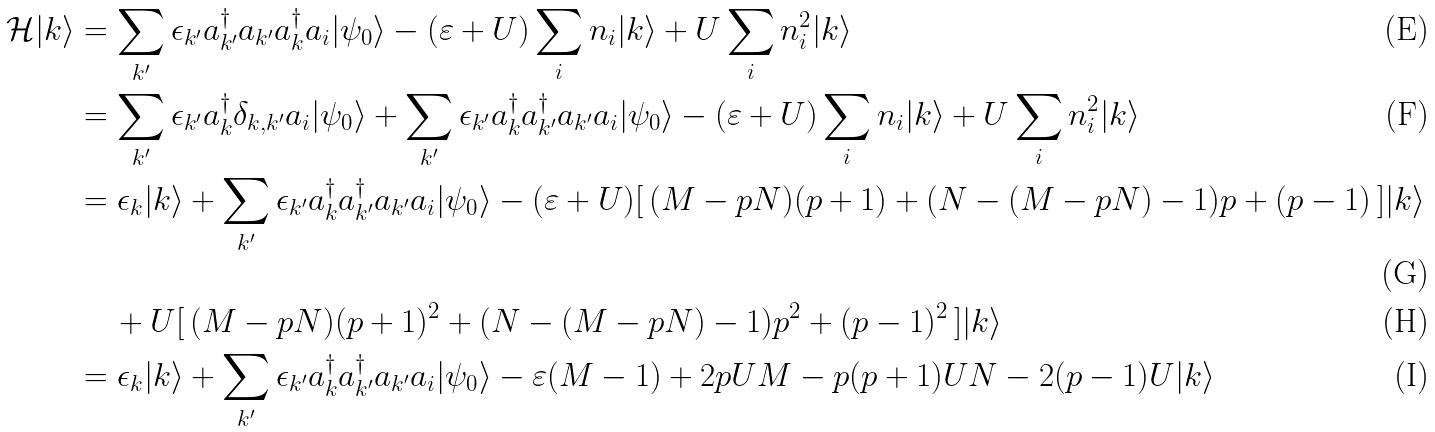<formula> <loc_0><loc_0><loc_500><loc_500>\mathcal { H } | { k } \rangle & = \sum _ { { k } ^ { \prime } } \epsilon _ { { k } ^ { \prime } } a _ { { k } ^ { \prime } } ^ { \dagger } a _ { { k } ^ { \prime } } a _ { k } ^ { \dagger } a _ { i } | \psi _ { 0 } \rangle - ( \varepsilon + U ) \sum _ { i } n _ { i } | { k } \rangle + U \sum _ { i } n _ { i } ^ { 2 } | { k } \rangle \\ & = \sum _ { { k } ^ { \prime } } \epsilon _ { { k } ^ { \prime } } a _ { k } ^ { \dagger } \delta _ { { k } , { { k } ^ { \prime } } } a _ { i } | \psi _ { 0 } \rangle + \sum _ { { k } ^ { \prime } } \epsilon _ { { k } ^ { \prime } } a _ { k } ^ { \dagger } a _ { { k } ^ { \prime } } ^ { \dagger } a _ { { k } ^ { \prime } } a _ { i } | \psi _ { 0 } \rangle - ( \varepsilon + U ) \sum _ { i } n _ { i } | { k } \rangle + U \sum _ { i } n _ { i } ^ { 2 } | { k } \rangle \\ & = \epsilon _ { k } | { k } \rangle + \sum _ { { k } ^ { \prime } } \epsilon _ { { k } ^ { \prime } } a _ { k } ^ { \dagger } a _ { { k } ^ { \prime } } ^ { \dagger } a _ { { k } ^ { \prime } } a _ { i } | \psi _ { 0 } \rangle - ( \varepsilon + U ) [ \, ( M - p N ) ( p + 1 ) + ( N - ( M - p N ) - 1 ) p + ( p - 1 ) \, ] | { k } \rangle \\ & \quad \, + U [ \, ( M - p N ) ( p + 1 ) ^ { 2 } + ( N - ( M - p N ) - 1 ) p ^ { 2 } + ( p - 1 ) ^ { 2 } \, ] | { k } \rangle \\ & = \epsilon _ { k } | { k } \rangle + \sum _ { { k } ^ { \prime } } \epsilon _ { { k } ^ { \prime } } a _ { k } ^ { \dagger } a _ { { k } ^ { \prime } } ^ { \dagger } a _ { { k } ^ { \prime } } a _ { i } | \psi _ { 0 } \rangle - \varepsilon ( M - 1 ) + 2 p U M - p ( p + 1 ) U N - 2 ( p - 1 ) U | { k } \rangle</formula> 